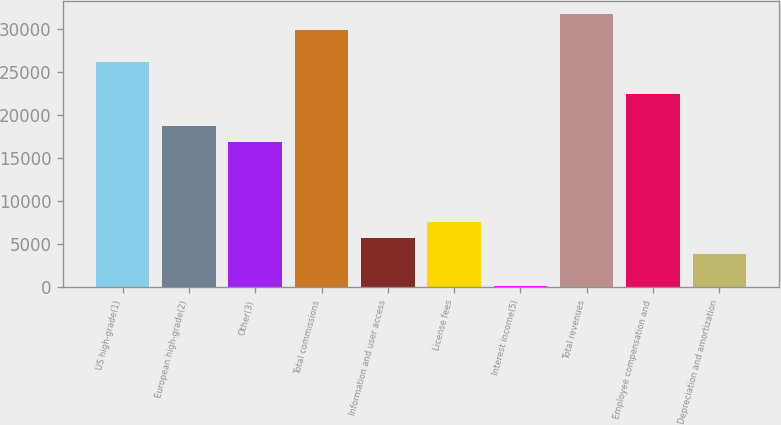Convert chart. <chart><loc_0><loc_0><loc_500><loc_500><bar_chart><fcel>US high-grade(1)<fcel>European high-grade(2)<fcel>Other(3)<fcel>Total commissions<fcel>Information and user access<fcel>License fees<fcel>Interest income(5)<fcel>Total revenues<fcel>Employee compensation and<fcel>Depreciation and amortization<nl><fcel>26136.8<fcel>18718<fcel>16863.3<fcel>29846.2<fcel>5735.1<fcel>7589.8<fcel>171<fcel>31700.9<fcel>22427.4<fcel>3880.4<nl></chart> 